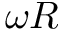<formula> <loc_0><loc_0><loc_500><loc_500>\omega R</formula> 